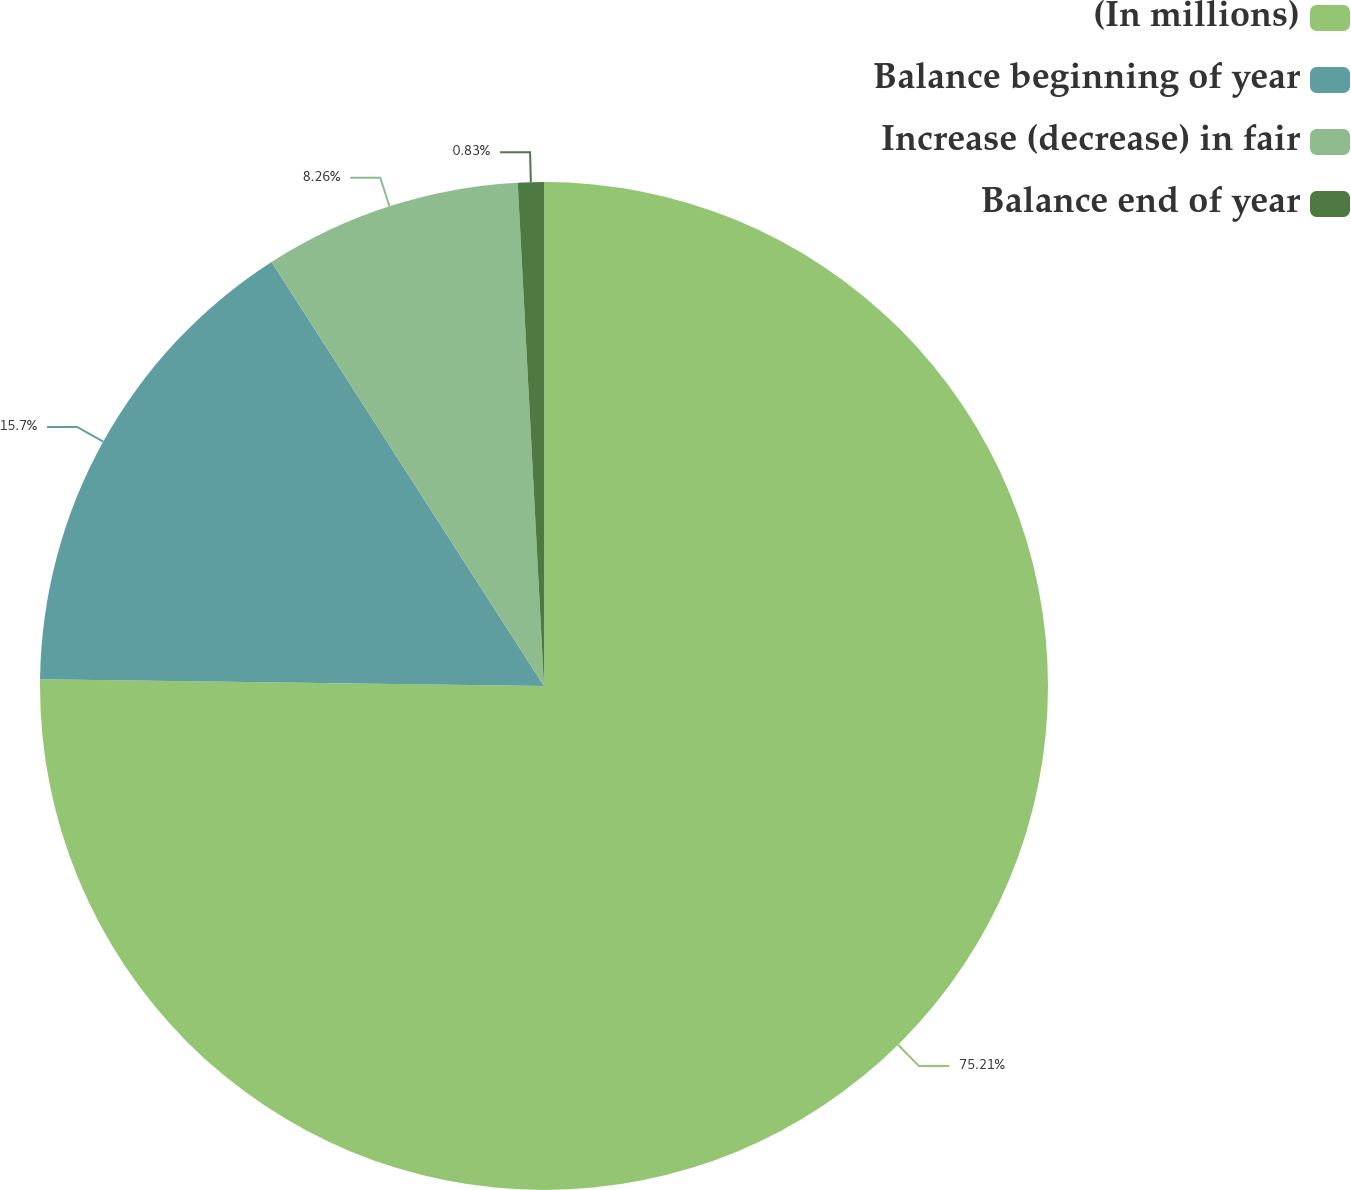Convert chart to OTSL. <chart><loc_0><loc_0><loc_500><loc_500><pie_chart><fcel>(In millions)<fcel>Balance beginning of year<fcel>Increase (decrease) in fair<fcel>Balance end of year<nl><fcel>75.21%<fcel>15.7%<fcel>8.26%<fcel>0.83%<nl></chart> 